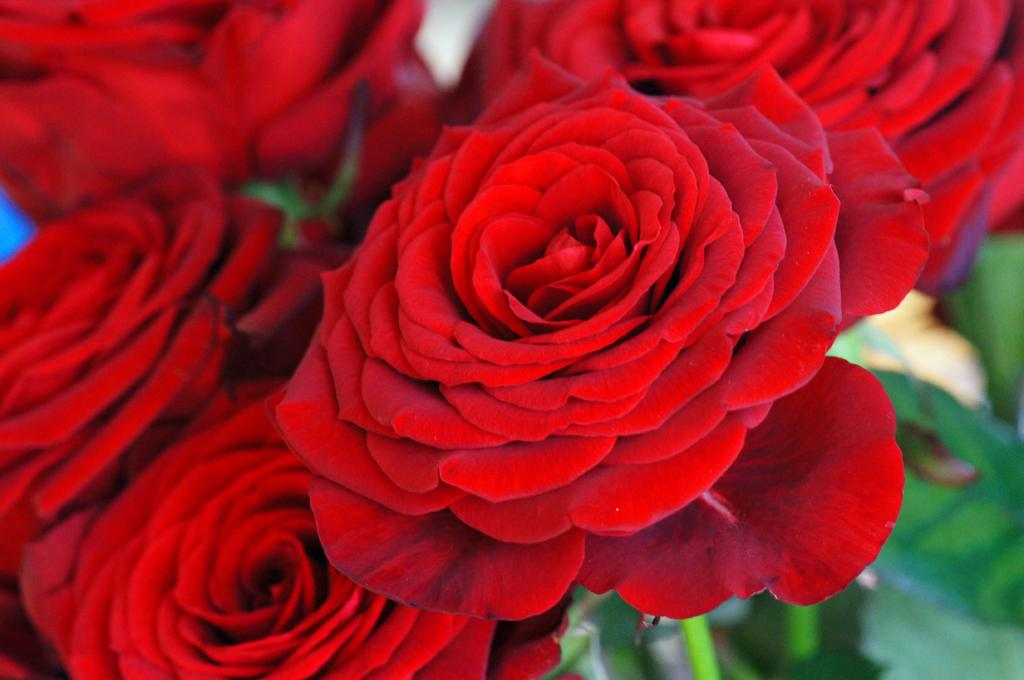What type of flowers are present in the image? There is a bunch of rose flowers in the image. How many flowers are in the bunch? The number of flowers in the bunch cannot be determined from the image alone. What is the color of the roses? The color of the roses cannot be determined from the image alone. Are there any other objects or flowers present in the image? The image only shows a bunch of rose flowers. Can you tell me how many dogs are running in the background of the image? There are no dogs or any running activity present in the image; it only shows a bunch of rose flowers. 